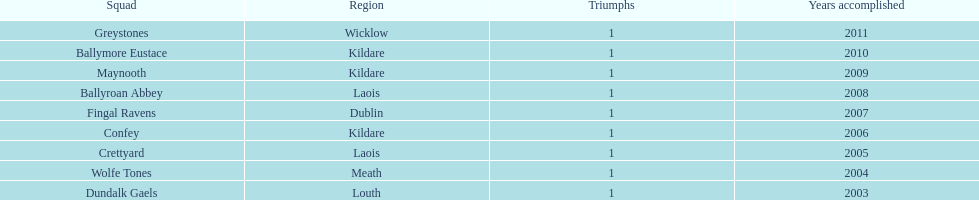Ballymore eustace is from the same county as what team that won in 2009? Maynooth. 